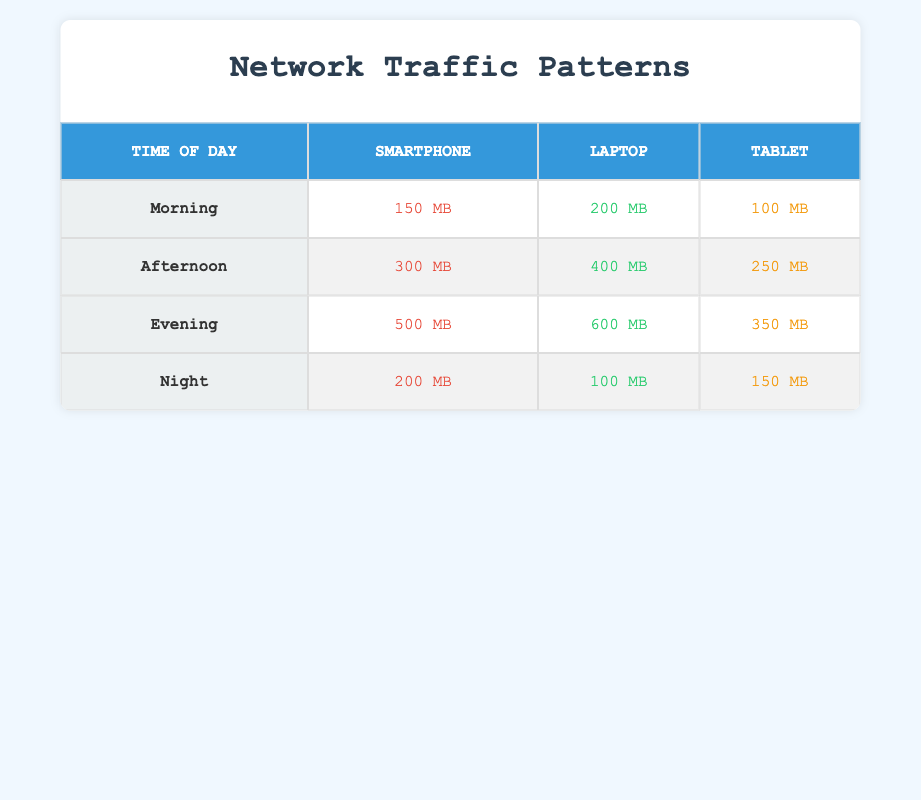What is the data usage for smartphones in the morning? According to the table, the data usage for smartphones during the morning time is specifically listed in the corresponding row under the 'Smartphone' column for 'Morning'. The value is 150 MB.
Answer: 150 MB Which device type has the highest data usage in the evening? In the evening row of the table, we compare the data usage values for each device type. The 'Laptop' has the highest data usage at 600 MB compared to smartphones at 500 MB and tablets at 350 MB.
Answer: Laptop What is the total data usage for tablets across all times of the day? We need to sum the data usage values for 'Tablet' in each time of day. The values are 100 MB (Morning) + 250 MB (Afternoon) + 350 MB (Evening) + 150 MB (Night) = 850 MB.
Answer: 850 MB Is the smartphone data usage higher in the afternoon than in the morning? By checking the table, the data usage for smartphones in the afternoon is 300 MB, while in the morning, it is 150 MB. Since 300 MB is greater than 150 MB, the statement is true.
Answer: Yes What is the average data usage of laptops throughout the day? To find the average, we need to sum the laptop data usage across all times: 200 MB (Morning) + 400 MB (Afternoon) + 600 MB (Evening) + 100 MB (Night) = 1300 MB. Then, we divide by 4 (the number of time slots): 1300 MB / 4 = 325 MB.
Answer: 325 MB Which time of day has the highest overall data usage across all device types? First, we calculate the total data usage for each time of day by summing all device types: Morning (150 + 200 + 100 = 450 MB), Afternoon (300 + 400 + 250 = 950 MB), Evening (500 + 600 + 350 = 1450 MB), Night (200 + 100 + 150 = 450 MB). The highest total is during the Evening at 1450 MB.
Answer: Evening Are there more data usage values for laptops that exceed 300 MB than for smartphones? The laptop values that exceed 300 MB are 400 MB (Afternoon) and 600 MB (Evening), totaling 2 instances. For smartphones, only the data usage in the evening (500 MB) exceeds 300 MB, so there is 1 instance. Therefore, there are more laptop values.
Answer: Yes What is the difference in data usage between smartphones and tablets in the afternoon? The data usage for smartphones in the afternoon is 300 MB and for tablets is 250 MB. To find the difference, we subtract the tablet usage from smartphone usage: 300 MB - 250 MB = 50 MB.
Answer: 50 MB 